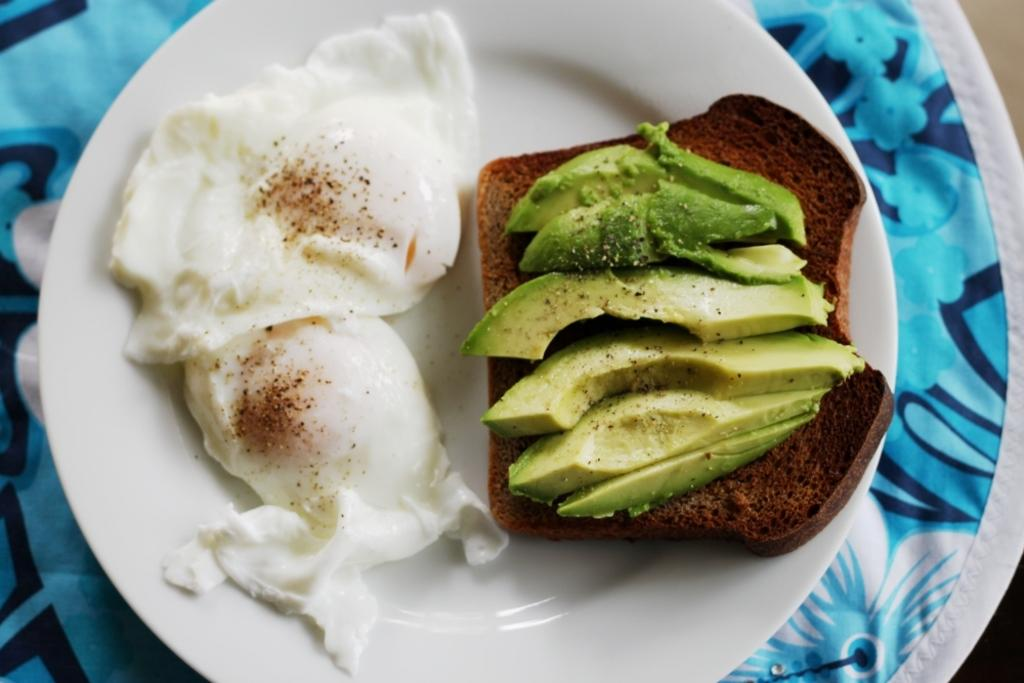What is on the plate that is visible in the image? There is food on a plate in the image. What is the color of the cloth that the plate is placed on? The plate is on a blue-colored cloth. What type of chicken is being operated on in the image? There is no chicken or operation present in the image. Is there a hat visible on the plate in the image? There is no hat present on the plate in the image. 